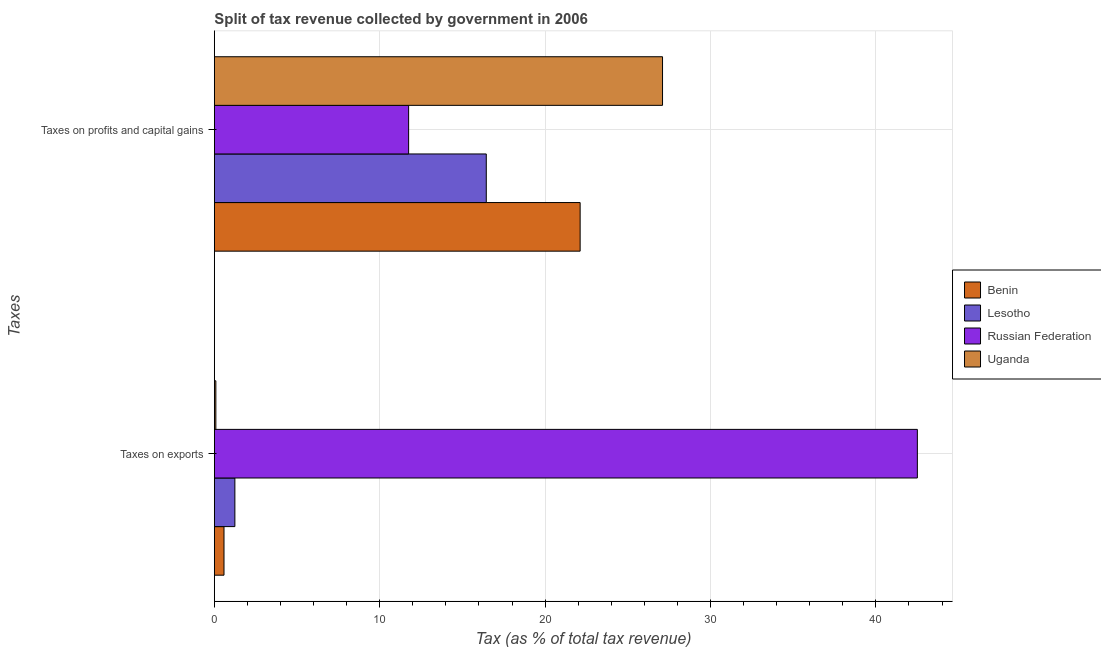Are the number of bars per tick equal to the number of legend labels?
Provide a short and direct response. Yes. Are the number of bars on each tick of the Y-axis equal?
Offer a very short reply. Yes. How many bars are there on the 2nd tick from the bottom?
Your response must be concise. 4. What is the label of the 2nd group of bars from the top?
Provide a short and direct response. Taxes on exports. What is the percentage of revenue obtained from taxes on exports in Benin?
Provide a short and direct response. 0.58. Across all countries, what is the maximum percentage of revenue obtained from taxes on exports?
Provide a short and direct response. 42.51. Across all countries, what is the minimum percentage of revenue obtained from taxes on profits and capital gains?
Your answer should be very brief. 11.75. In which country was the percentage of revenue obtained from taxes on exports maximum?
Your answer should be compact. Russian Federation. In which country was the percentage of revenue obtained from taxes on exports minimum?
Your response must be concise. Uganda. What is the total percentage of revenue obtained from taxes on profits and capital gains in the graph?
Ensure brevity in your answer.  77.41. What is the difference between the percentage of revenue obtained from taxes on exports in Benin and that in Lesotho?
Ensure brevity in your answer.  -0.66. What is the difference between the percentage of revenue obtained from taxes on profits and capital gains in Russian Federation and the percentage of revenue obtained from taxes on exports in Uganda?
Provide a short and direct response. 11.66. What is the average percentage of revenue obtained from taxes on exports per country?
Make the answer very short. 11.11. What is the difference between the percentage of revenue obtained from taxes on profits and capital gains and percentage of revenue obtained from taxes on exports in Uganda?
Your answer should be very brief. 27.01. What is the ratio of the percentage of revenue obtained from taxes on exports in Lesotho to that in Russian Federation?
Provide a succinct answer. 0.03. Is the percentage of revenue obtained from taxes on profits and capital gains in Lesotho less than that in Benin?
Offer a very short reply. Yes. What does the 3rd bar from the top in Taxes on exports represents?
Provide a succinct answer. Lesotho. What does the 4th bar from the bottom in Taxes on exports represents?
Keep it short and to the point. Uganda. Are all the bars in the graph horizontal?
Provide a short and direct response. Yes. How many countries are there in the graph?
Offer a terse response. 4. Are the values on the major ticks of X-axis written in scientific E-notation?
Offer a terse response. No. How many legend labels are there?
Provide a succinct answer. 4. What is the title of the graph?
Offer a very short reply. Split of tax revenue collected by government in 2006. What is the label or title of the X-axis?
Give a very brief answer. Tax (as % of total tax revenue). What is the label or title of the Y-axis?
Give a very brief answer. Taxes. What is the Tax (as % of total tax revenue) in Benin in Taxes on exports?
Your answer should be compact. 0.58. What is the Tax (as % of total tax revenue) of Lesotho in Taxes on exports?
Make the answer very short. 1.24. What is the Tax (as % of total tax revenue) of Russian Federation in Taxes on exports?
Your answer should be compact. 42.51. What is the Tax (as % of total tax revenue) of Uganda in Taxes on exports?
Offer a terse response. 0.09. What is the Tax (as % of total tax revenue) of Benin in Taxes on profits and capital gains?
Offer a very short reply. 22.12. What is the Tax (as % of total tax revenue) in Lesotho in Taxes on profits and capital gains?
Ensure brevity in your answer.  16.44. What is the Tax (as % of total tax revenue) in Russian Federation in Taxes on profits and capital gains?
Give a very brief answer. 11.75. What is the Tax (as % of total tax revenue) in Uganda in Taxes on profits and capital gains?
Keep it short and to the point. 27.1. Across all Taxes, what is the maximum Tax (as % of total tax revenue) of Benin?
Your answer should be very brief. 22.12. Across all Taxes, what is the maximum Tax (as % of total tax revenue) of Lesotho?
Offer a very short reply. 16.44. Across all Taxes, what is the maximum Tax (as % of total tax revenue) in Russian Federation?
Offer a very short reply. 42.51. Across all Taxes, what is the maximum Tax (as % of total tax revenue) in Uganda?
Make the answer very short. 27.1. Across all Taxes, what is the minimum Tax (as % of total tax revenue) of Benin?
Your response must be concise. 0.58. Across all Taxes, what is the minimum Tax (as % of total tax revenue) in Lesotho?
Offer a very short reply. 1.24. Across all Taxes, what is the minimum Tax (as % of total tax revenue) of Russian Federation?
Your response must be concise. 11.75. Across all Taxes, what is the minimum Tax (as % of total tax revenue) of Uganda?
Your response must be concise. 0.09. What is the total Tax (as % of total tax revenue) in Benin in the graph?
Offer a very short reply. 22.7. What is the total Tax (as % of total tax revenue) in Lesotho in the graph?
Provide a short and direct response. 17.68. What is the total Tax (as % of total tax revenue) of Russian Federation in the graph?
Offer a terse response. 54.26. What is the total Tax (as % of total tax revenue) in Uganda in the graph?
Provide a short and direct response. 27.19. What is the difference between the Tax (as % of total tax revenue) in Benin in Taxes on exports and that in Taxes on profits and capital gains?
Offer a terse response. -21.54. What is the difference between the Tax (as % of total tax revenue) of Lesotho in Taxes on exports and that in Taxes on profits and capital gains?
Offer a terse response. -15.2. What is the difference between the Tax (as % of total tax revenue) of Russian Federation in Taxes on exports and that in Taxes on profits and capital gains?
Provide a short and direct response. 30.76. What is the difference between the Tax (as % of total tax revenue) in Uganda in Taxes on exports and that in Taxes on profits and capital gains?
Give a very brief answer. -27.01. What is the difference between the Tax (as % of total tax revenue) of Benin in Taxes on exports and the Tax (as % of total tax revenue) of Lesotho in Taxes on profits and capital gains?
Your response must be concise. -15.86. What is the difference between the Tax (as % of total tax revenue) of Benin in Taxes on exports and the Tax (as % of total tax revenue) of Russian Federation in Taxes on profits and capital gains?
Ensure brevity in your answer.  -11.16. What is the difference between the Tax (as % of total tax revenue) of Benin in Taxes on exports and the Tax (as % of total tax revenue) of Uganda in Taxes on profits and capital gains?
Your answer should be very brief. -26.52. What is the difference between the Tax (as % of total tax revenue) in Lesotho in Taxes on exports and the Tax (as % of total tax revenue) in Russian Federation in Taxes on profits and capital gains?
Provide a succinct answer. -10.51. What is the difference between the Tax (as % of total tax revenue) of Lesotho in Taxes on exports and the Tax (as % of total tax revenue) of Uganda in Taxes on profits and capital gains?
Offer a very short reply. -25.86. What is the difference between the Tax (as % of total tax revenue) of Russian Federation in Taxes on exports and the Tax (as % of total tax revenue) of Uganda in Taxes on profits and capital gains?
Keep it short and to the point. 15.41. What is the average Tax (as % of total tax revenue) in Benin per Taxes?
Offer a very short reply. 11.35. What is the average Tax (as % of total tax revenue) of Lesotho per Taxes?
Provide a succinct answer. 8.84. What is the average Tax (as % of total tax revenue) of Russian Federation per Taxes?
Provide a short and direct response. 27.13. What is the average Tax (as % of total tax revenue) in Uganda per Taxes?
Offer a terse response. 13.6. What is the difference between the Tax (as % of total tax revenue) of Benin and Tax (as % of total tax revenue) of Lesotho in Taxes on exports?
Ensure brevity in your answer.  -0.66. What is the difference between the Tax (as % of total tax revenue) of Benin and Tax (as % of total tax revenue) of Russian Federation in Taxes on exports?
Offer a very short reply. -41.93. What is the difference between the Tax (as % of total tax revenue) in Benin and Tax (as % of total tax revenue) in Uganda in Taxes on exports?
Make the answer very short. 0.49. What is the difference between the Tax (as % of total tax revenue) of Lesotho and Tax (as % of total tax revenue) of Russian Federation in Taxes on exports?
Make the answer very short. -41.27. What is the difference between the Tax (as % of total tax revenue) in Lesotho and Tax (as % of total tax revenue) in Uganda in Taxes on exports?
Your answer should be compact. 1.15. What is the difference between the Tax (as % of total tax revenue) in Russian Federation and Tax (as % of total tax revenue) in Uganda in Taxes on exports?
Offer a terse response. 42.42. What is the difference between the Tax (as % of total tax revenue) in Benin and Tax (as % of total tax revenue) in Lesotho in Taxes on profits and capital gains?
Your answer should be very brief. 5.68. What is the difference between the Tax (as % of total tax revenue) in Benin and Tax (as % of total tax revenue) in Russian Federation in Taxes on profits and capital gains?
Provide a succinct answer. 10.37. What is the difference between the Tax (as % of total tax revenue) in Benin and Tax (as % of total tax revenue) in Uganda in Taxes on profits and capital gains?
Your answer should be very brief. -4.98. What is the difference between the Tax (as % of total tax revenue) of Lesotho and Tax (as % of total tax revenue) of Russian Federation in Taxes on profits and capital gains?
Your answer should be compact. 4.7. What is the difference between the Tax (as % of total tax revenue) in Lesotho and Tax (as % of total tax revenue) in Uganda in Taxes on profits and capital gains?
Your answer should be very brief. -10.66. What is the difference between the Tax (as % of total tax revenue) in Russian Federation and Tax (as % of total tax revenue) in Uganda in Taxes on profits and capital gains?
Offer a terse response. -15.35. What is the ratio of the Tax (as % of total tax revenue) in Benin in Taxes on exports to that in Taxes on profits and capital gains?
Offer a terse response. 0.03. What is the ratio of the Tax (as % of total tax revenue) of Lesotho in Taxes on exports to that in Taxes on profits and capital gains?
Provide a succinct answer. 0.08. What is the ratio of the Tax (as % of total tax revenue) of Russian Federation in Taxes on exports to that in Taxes on profits and capital gains?
Keep it short and to the point. 3.62. What is the ratio of the Tax (as % of total tax revenue) in Uganda in Taxes on exports to that in Taxes on profits and capital gains?
Your response must be concise. 0. What is the difference between the highest and the second highest Tax (as % of total tax revenue) in Benin?
Make the answer very short. 21.54. What is the difference between the highest and the second highest Tax (as % of total tax revenue) in Lesotho?
Keep it short and to the point. 15.2. What is the difference between the highest and the second highest Tax (as % of total tax revenue) of Russian Federation?
Make the answer very short. 30.76. What is the difference between the highest and the second highest Tax (as % of total tax revenue) of Uganda?
Your answer should be compact. 27.01. What is the difference between the highest and the lowest Tax (as % of total tax revenue) in Benin?
Offer a very short reply. 21.54. What is the difference between the highest and the lowest Tax (as % of total tax revenue) in Lesotho?
Ensure brevity in your answer.  15.2. What is the difference between the highest and the lowest Tax (as % of total tax revenue) in Russian Federation?
Ensure brevity in your answer.  30.76. What is the difference between the highest and the lowest Tax (as % of total tax revenue) in Uganda?
Keep it short and to the point. 27.01. 